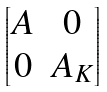<formula> <loc_0><loc_0><loc_500><loc_500>\begin{bmatrix} A & 0 \\ 0 & A _ { K } \end{bmatrix}</formula> 